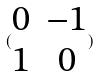Convert formula to latex. <formula><loc_0><loc_0><loc_500><loc_500>( \begin{matrix} 0 & - 1 \\ 1 & 0 \end{matrix} )</formula> 